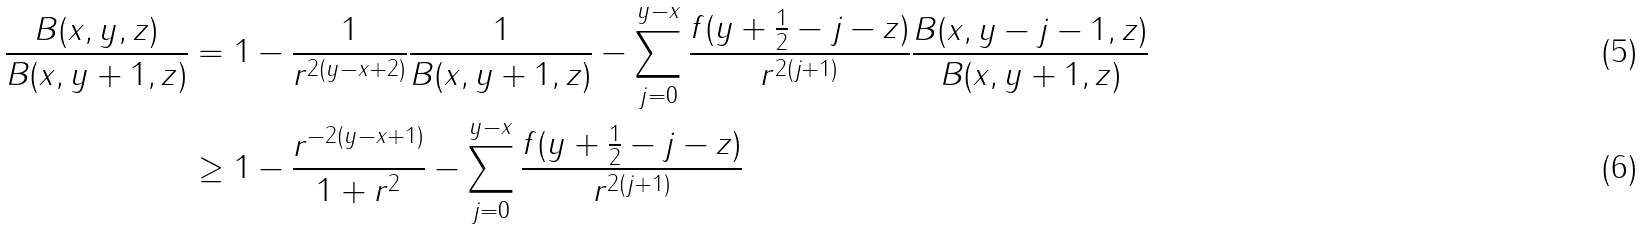Convert formula to latex. <formula><loc_0><loc_0><loc_500><loc_500>\frac { B ( x , y , z ) } { B ( x , y + 1 , z ) } & = 1 - \frac { 1 } { r ^ { 2 ( y - x + 2 ) } } \frac { 1 } { B ( x , y + 1 , z ) } - \sum _ { j = 0 } ^ { y - x } \frac { f ( y + \frac { 1 } { 2 } - j - z ) } { r ^ { 2 ( j + 1 ) } } \frac { B ( x , y - j - 1 , z ) } { B ( x , y + 1 , z ) } \\ & \geq 1 - \frac { r ^ { - 2 ( y - x + 1 ) } } { 1 + r ^ { 2 } } - \sum _ { j = 0 } ^ { y - x } \frac { f ( y + \frac { 1 } { 2 } - j - z ) } { r ^ { 2 ( j + 1 ) } }</formula> 